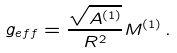Convert formula to latex. <formula><loc_0><loc_0><loc_500><loc_500>g _ { e f f } = \frac { \sqrt { A ^ { ( 1 ) } } } { R ^ { 2 } } M ^ { ( 1 ) } \, .</formula> 